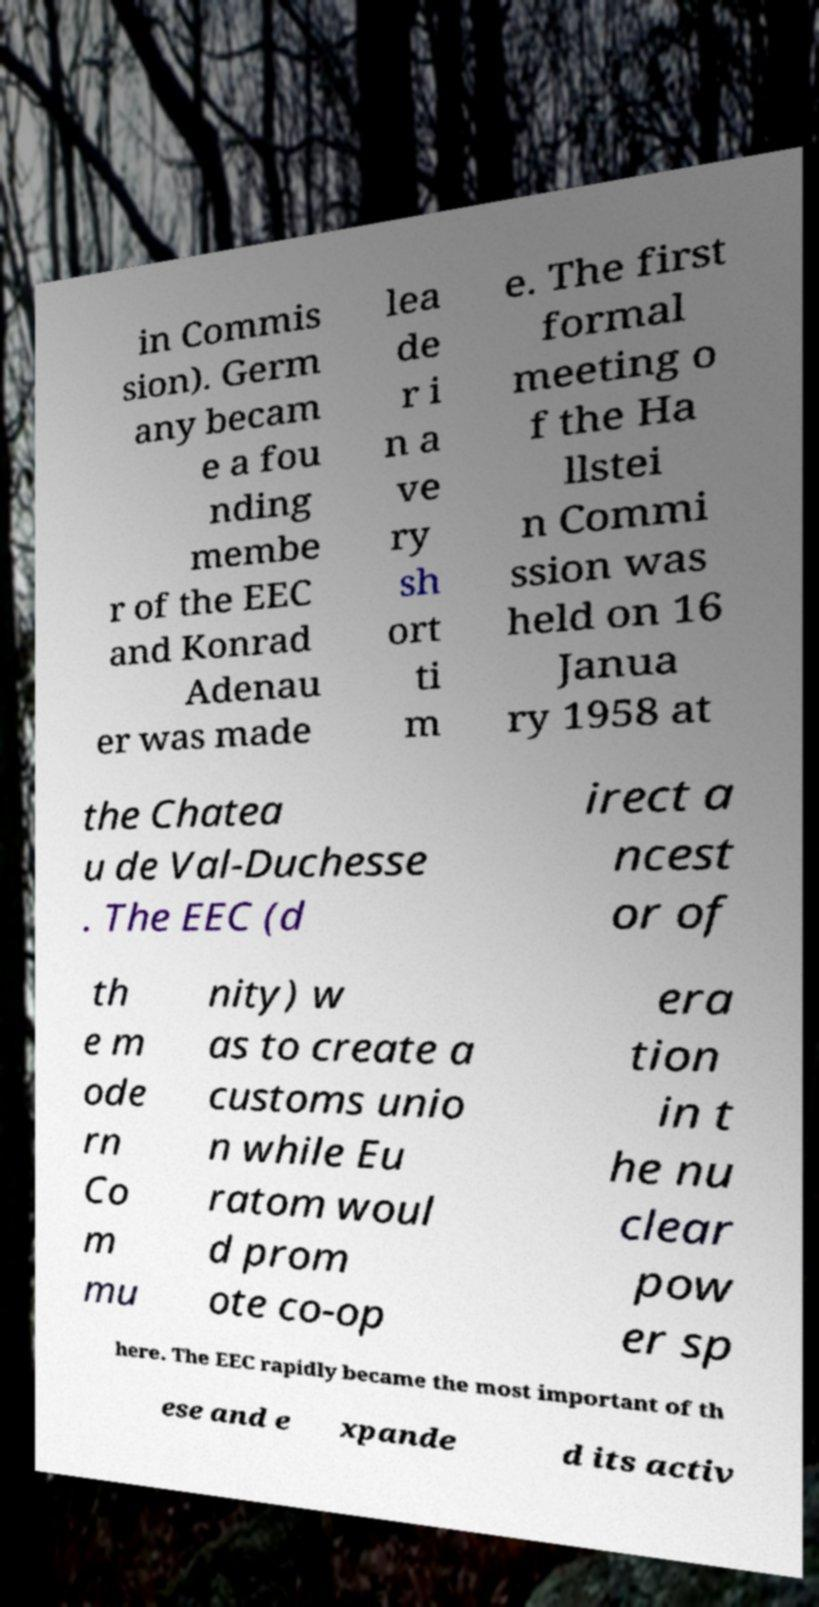I need the written content from this picture converted into text. Can you do that? in Commis sion). Germ any becam e a fou nding membe r of the EEC and Konrad Adenau er was made lea de r i n a ve ry sh ort ti m e. The first formal meeting o f the Ha llstei n Commi ssion was held on 16 Janua ry 1958 at the Chatea u de Val-Duchesse . The EEC (d irect a ncest or of th e m ode rn Co m mu nity) w as to create a customs unio n while Eu ratom woul d prom ote co-op era tion in t he nu clear pow er sp here. The EEC rapidly became the most important of th ese and e xpande d its activ 